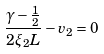<formula> <loc_0><loc_0><loc_500><loc_500>\frac { \gamma - \frac { 1 } { 2 } } { 2 \xi _ { 2 } L } - v _ { 2 } = 0</formula> 